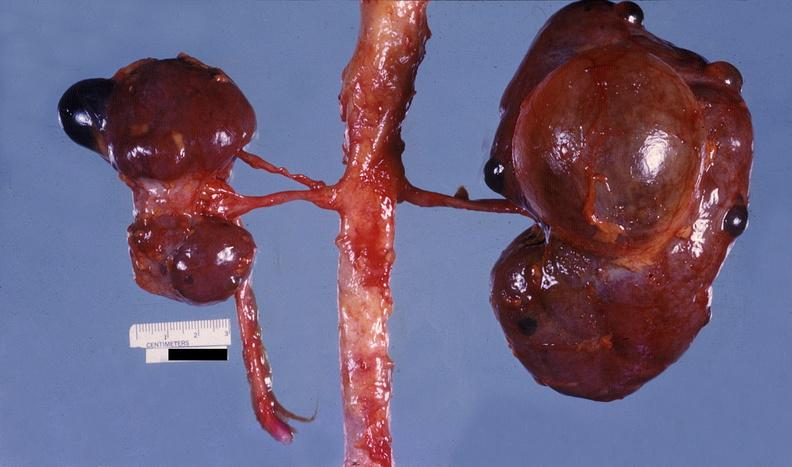where is this?
Answer the question using a single word or phrase. Urinary 